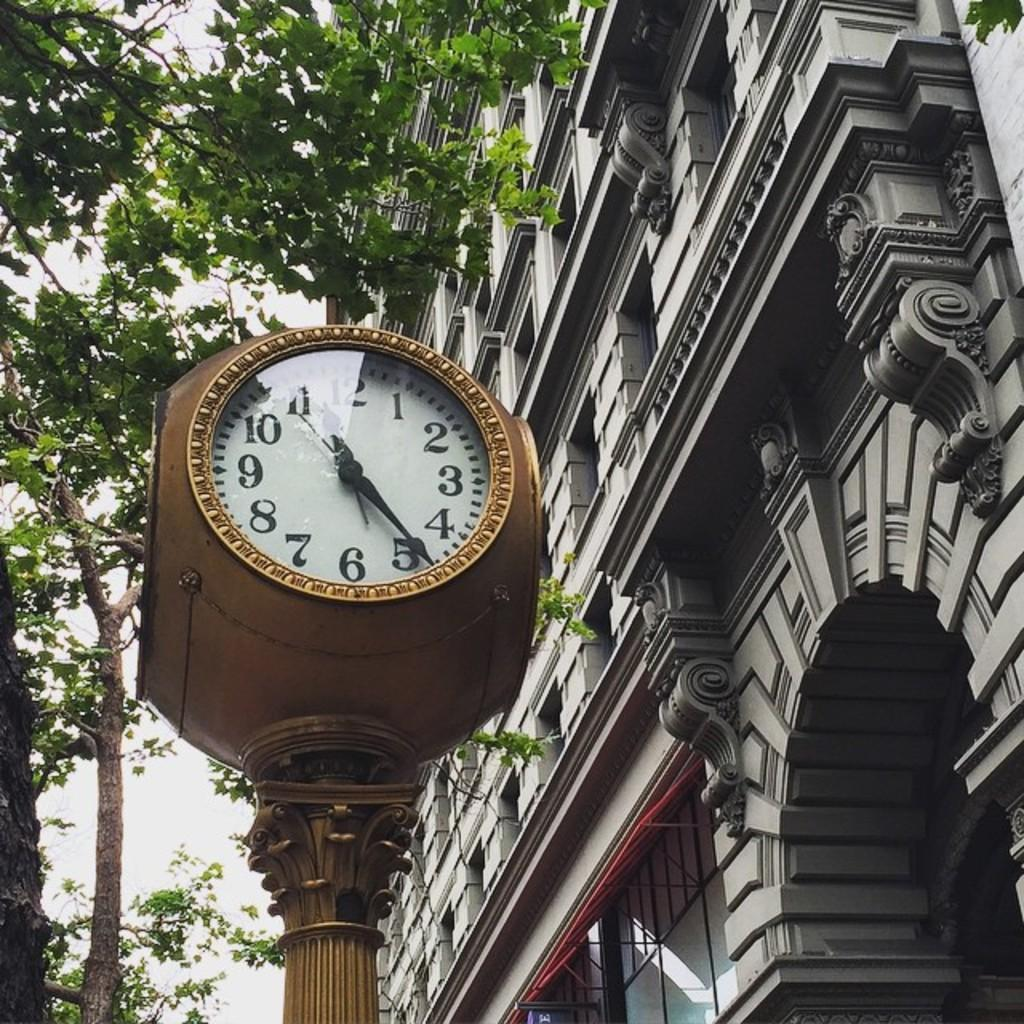What is the main object in the middle of the image? There is a clock in the middle of the image. What type of vegetation is on the left side of the image? There are trees on the left side of the image. What type of structure is on the right side of the image? There is a building on the right side of the image. Can you tell me how many nails are holding the clock in place in the image? There is no mention of nails in the image, and the clock's method of attachment is not visible. 